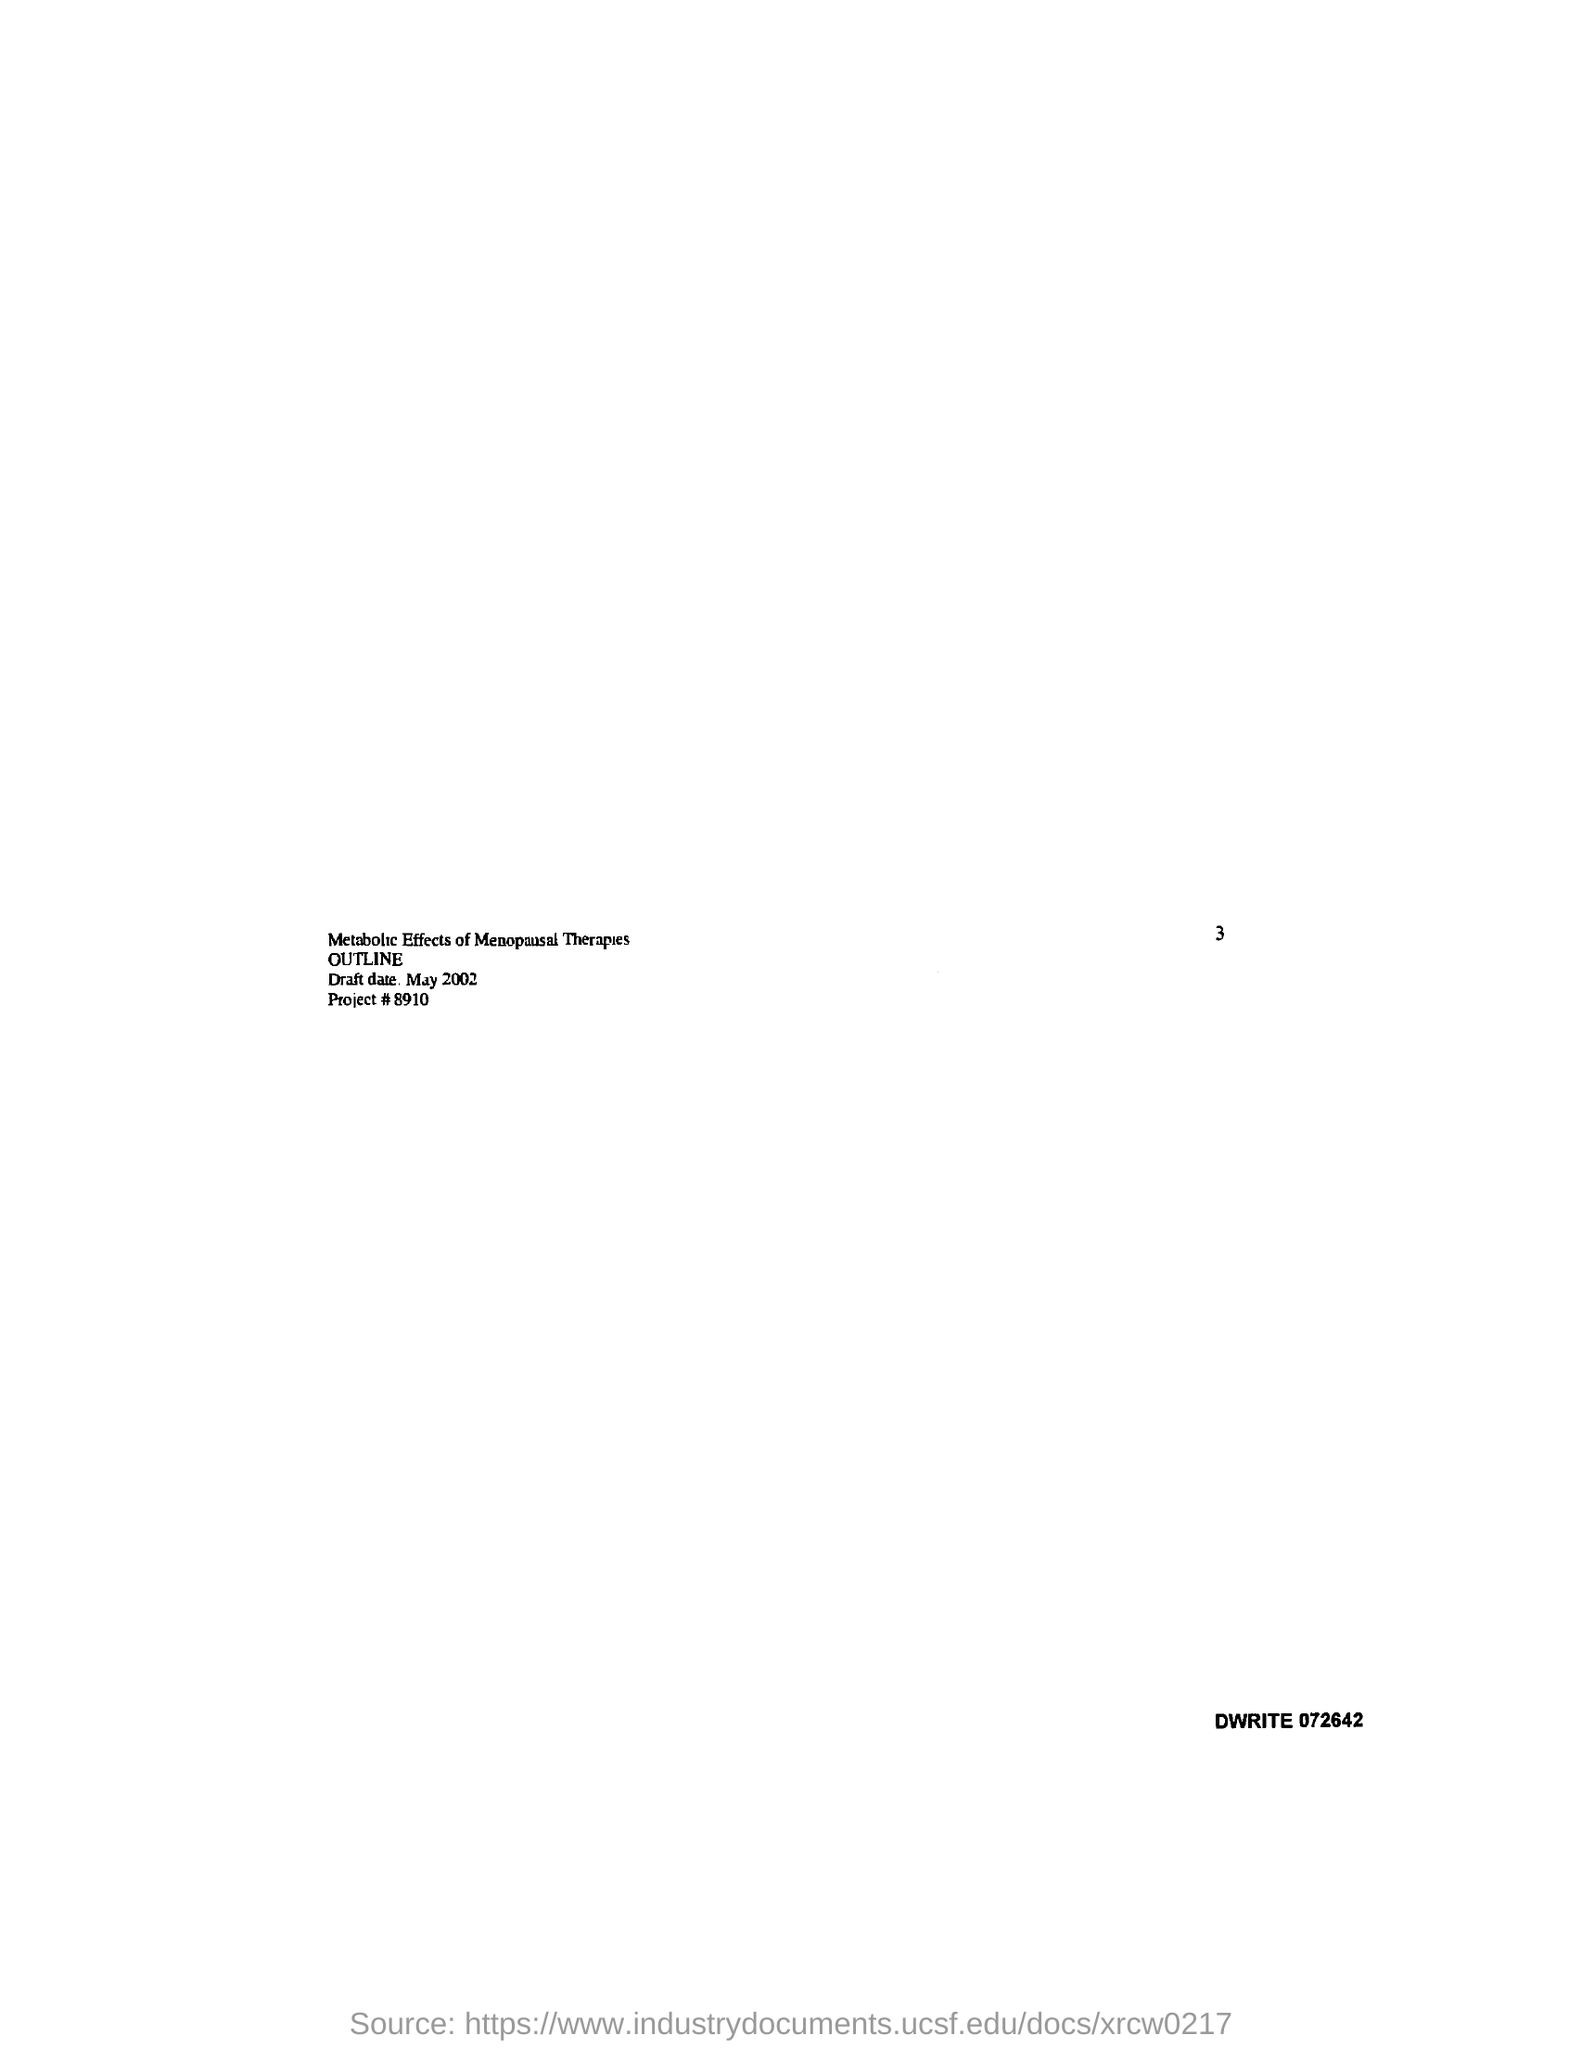List a handful of essential elements in this visual. The draft date is in May 2002. The title of the draft is "Metabolic Effects of Menopausal Therapies. What is the project number? It is 8910. 